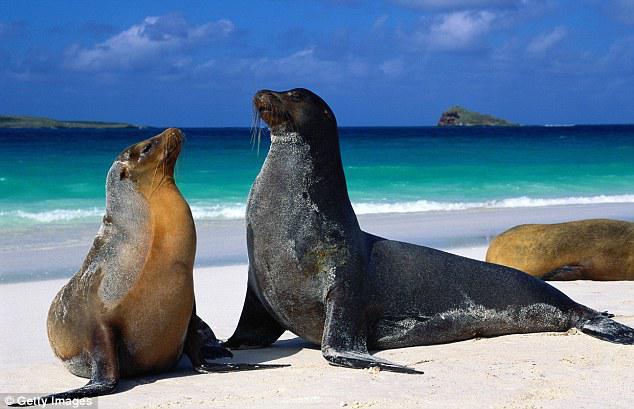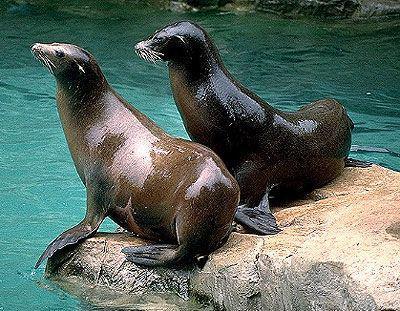The first image is the image on the left, the second image is the image on the right. Evaluate the accuracy of this statement regarding the images: "The right image contains exactly two seals.". Is it true? Answer yes or no. Yes. 